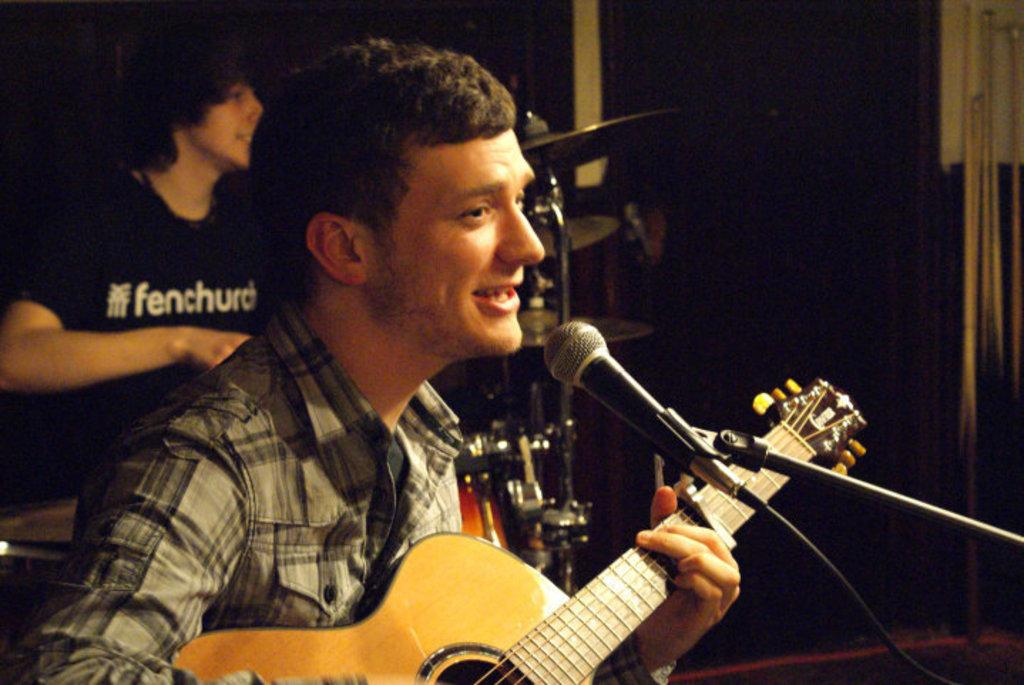What is the man in the image holding? The man is holding a guitar in the image. What is the man doing with the guitar? The man is playing the guitar. Is the man singing in the image? Yes, the man is singing a song through a mic. What other musician can be seen in the image? There is a man playing electronic drums in the background of the image. How much wealth does the crate in the image contain? There is no crate present in the image, so it is not possible to determine its contents or value. 